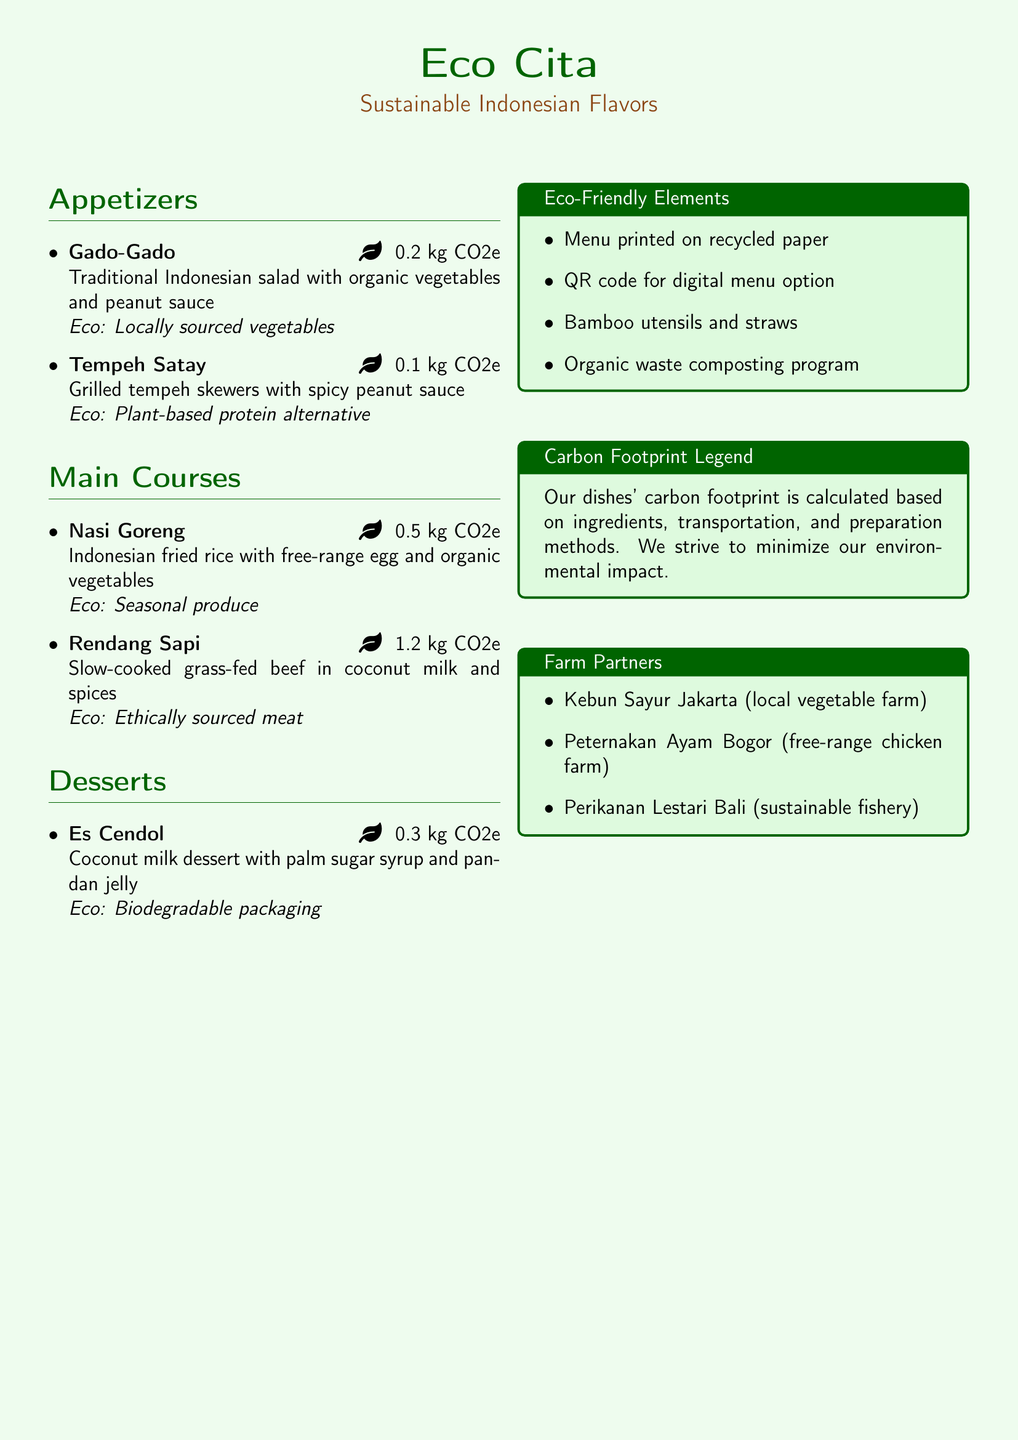what is the name of the restaurant? The restaurant name is prominently displayed at the top of the menu.
Answer: Eco Cita how many carbon footprint does Gado-Gado have? The carbon footprint for Gado-Gado is listed next to the dish description.
Answer: 0.2 kg CO2e which farm provides local vegetables? The document lists farm partners that contribute to the restaurant's menu.
Answer: Kebun Sayur Jakarta what is the carbon footprint of Rendang Sapi? Rendang Sapi's carbon footprint is mentioned in the main courses section.
Answer: 1.2 kg CO2e what type of utensils does the restaurant use? The eco-friendly elements section mentions the types of utensils used.
Answer: Bamboo utensils what type of dessert is Es Cendol? Es Cendol is categorized under the desserts section of the menu.
Answer: Coconut milk dessert how many eco-friendly items are listed in the menu’s eco-friendly elements? The number of eco-friendly items can be counted in the specified section.
Answer: Four what is the main ingredient in Tempeh Satay? The key ingredient for Tempeh Satay is described in the dish details.
Answer: Tempeh which company provides free-range chicken? The farm partners section specifies the provider of free-range chicken.
Answer: Peternakan Ayam Bogor 